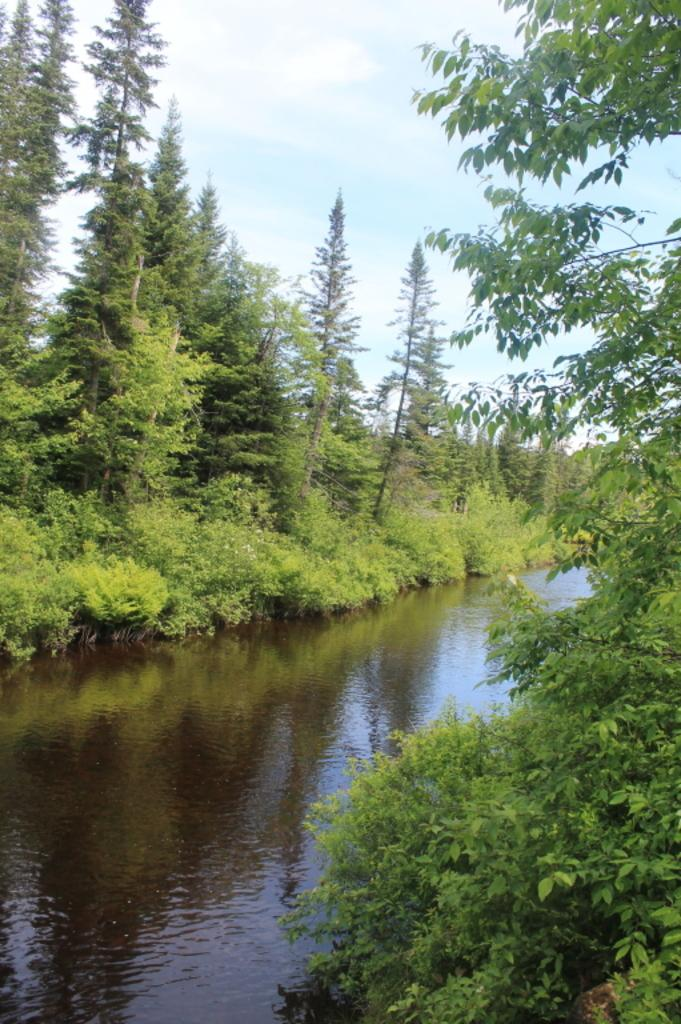What is the main subject in the center of the image? There is water in the center of the image. What type of vegetation can be seen on both sides of the image? There are trees on both sides of the image. What is visible at the top of the image? The sky is visible at the top of the image. What part of the nation is depicted in the image? The image does not depict a specific part of a nation; it features water, trees, and the sky. How many hands are visible in the image? There are no hands visible in the image. 